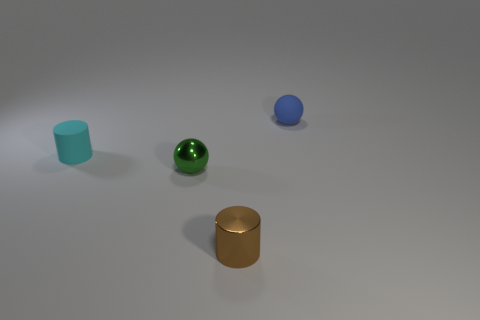Add 2 spheres. How many objects exist? 6 Subtract all green things. Subtract all tiny cyan objects. How many objects are left? 2 Add 1 small cyan rubber cylinders. How many small cyan rubber cylinders are left? 2 Add 2 small purple rubber blocks. How many small purple rubber blocks exist? 2 Subtract 0 gray cylinders. How many objects are left? 4 